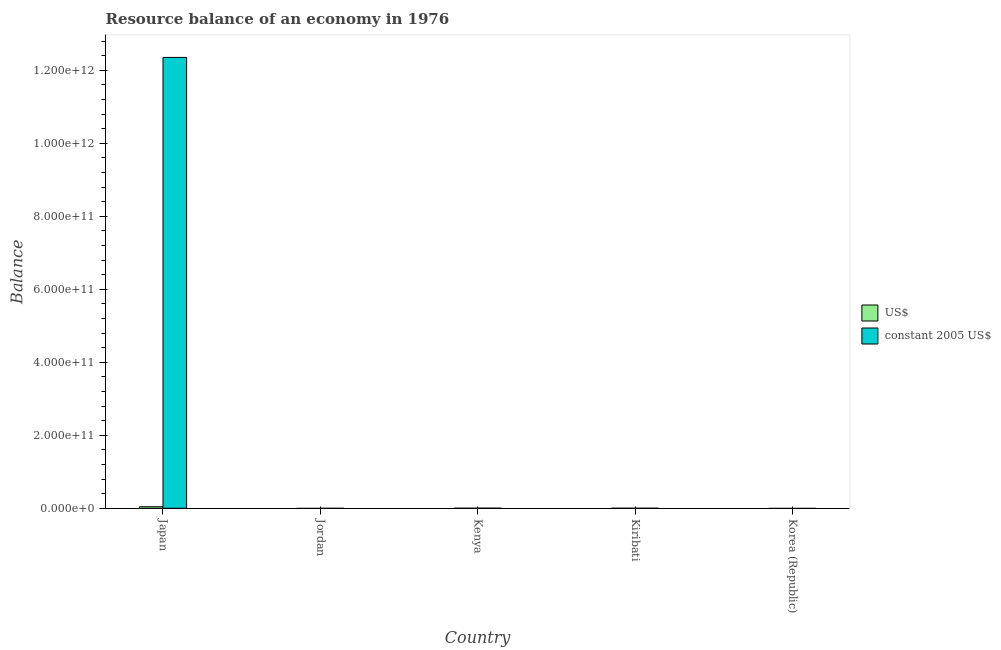How many different coloured bars are there?
Keep it short and to the point. 2. Are the number of bars per tick equal to the number of legend labels?
Provide a succinct answer. No. What is the label of the 2nd group of bars from the left?
Your response must be concise. Jordan. In how many cases, is the number of bars for a given country not equal to the number of legend labels?
Keep it short and to the point. 2. Across all countries, what is the maximum resource balance in us$?
Your answer should be compact. 4.17e+09. In which country was the resource balance in us$ maximum?
Provide a short and direct response. Japan. What is the total resource balance in us$ in the graph?
Offer a very short reply. 4.20e+09. What is the difference between the resource balance in constant us$ in Japan and that in Kiribati?
Your answer should be compact. 1.24e+12. What is the difference between the resource balance in constant us$ in Japan and the resource balance in us$ in Korea (Republic)?
Offer a terse response. 1.24e+12. What is the average resource balance in constant us$ per country?
Your response must be concise. 2.47e+11. What is the difference between the resource balance in constant us$ and resource balance in us$ in Kiribati?
Provide a short and direct response. -1.55e+06. What is the difference between the highest and the second highest resource balance in constant us$?
Ensure brevity in your answer.  1.24e+12. What is the difference between the highest and the lowest resource balance in us$?
Your answer should be compact. 4.17e+09. In how many countries, is the resource balance in us$ greater than the average resource balance in us$ taken over all countries?
Your response must be concise. 1. Is the sum of the resource balance in constant us$ in Kenya and Kiribati greater than the maximum resource balance in us$ across all countries?
Your response must be concise. No. How many bars are there?
Offer a terse response. 6. Are all the bars in the graph horizontal?
Give a very brief answer. No. How many countries are there in the graph?
Offer a very short reply. 5. What is the difference between two consecutive major ticks on the Y-axis?
Provide a short and direct response. 2.00e+11. Are the values on the major ticks of Y-axis written in scientific E-notation?
Your answer should be compact. Yes. Does the graph contain any zero values?
Provide a short and direct response. Yes. How many legend labels are there?
Make the answer very short. 2. How are the legend labels stacked?
Provide a short and direct response. Vertical. What is the title of the graph?
Provide a short and direct response. Resource balance of an economy in 1976. Does "From production" appear as one of the legend labels in the graph?
Offer a terse response. No. What is the label or title of the X-axis?
Provide a short and direct response. Country. What is the label or title of the Y-axis?
Ensure brevity in your answer.  Balance. What is the Balance in US$ in Japan?
Offer a terse response. 4.17e+09. What is the Balance in constant 2005 US$ in Japan?
Your response must be concise. 1.24e+12. What is the Balance of constant 2005 US$ in Jordan?
Make the answer very short. 0. What is the Balance of US$ in Kenya?
Provide a short and direct response. 2.41e+07. What is the Balance in constant 2005 US$ in Kenya?
Offer a terse response. 2.02e+08. What is the Balance of US$ in Kiribati?
Keep it short and to the point. 8.51e+06. What is the Balance in constant 2005 US$ in Kiribati?
Provide a succinct answer. 6.96e+06. What is the Balance in US$ in Korea (Republic)?
Your answer should be compact. 0. What is the Balance in constant 2005 US$ in Korea (Republic)?
Provide a short and direct response. 0. Across all countries, what is the maximum Balance in US$?
Keep it short and to the point. 4.17e+09. Across all countries, what is the maximum Balance of constant 2005 US$?
Ensure brevity in your answer.  1.24e+12. Across all countries, what is the minimum Balance of US$?
Give a very brief answer. 0. What is the total Balance in US$ in the graph?
Your answer should be compact. 4.20e+09. What is the total Balance of constant 2005 US$ in the graph?
Your answer should be compact. 1.24e+12. What is the difference between the Balance in US$ in Japan and that in Kenya?
Your answer should be compact. 4.14e+09. What is the difference between the Balance in constant 2005 US$ in Japan and that in Kenya?
Offer a very short reply. 1.24e+12. What is the difference between the Balance in US$ in Japan and that in Kiribati?
Offer a terse response. 4.16e+09. What is the difference between the Balance of constant 2005 US$ in Japan and that in Kiribati?
Ensure brevity in your answer.  1.24e+12. What is the difference between the Balance of US$ in Kenya and that in Kiribati?
Provide a succinct answer. 1.56e+07. What is the difference between the Balance in constant 2005 US$ in Kenya and that in Kiribati?
Your answer should be compact. 1.95e+08. What is the difference between the Balance in US$ in Japan and the Balance in constant 2005 US$ in Kenya?
Offer a very short reply. 3.96e+09. What is the difference between the Balance in US$ in Japan and the Balance in constant 2005 US$ in Kiribati?
Your response must be concise. 4.16e+09. What is the difference between the Balance in US$ in Kenya and the Balance in constant 2005 US$ in Kiribati?
Provide a short and direct response. 1.72e+07. What is the average Balance in US$ per country?
Provide a short and direct response. 8.40e+08. What is the average Balance in constant 2005 US$ per country?
Offer a very short reply. 2.47e+11. What is the difference between the Balance of US$ and Balance of constant 2005 US$ in Japan?
Offer a terse response. -1.23e+12. What is the difference between the Balance in US$ and Balance in constant 2005 US$ in Kenya?
Offer a very short reply. -1.78e+08. What is the difference between the Balance in US$ and Balance in constant 2005 US$ in Kiribati?
Make the answer very short. 1.55e+06. What is the ratio of the Balance of US$ in Japan to that in Kenya?
Provide a succinct answer. 172.54. What is the ratio of the Balance of constant 2005 US$ in Japan to that in Kenya?
Offer a terse response. 6115.22. What is the ratio of the Balance in US$ in Japan to that in Kiribati?
Offer a terse response. 489.53. What is the ratio of the Balance of constant 2005 US$ in Japan to that in Kiribati?
Offer a terse response. 1.77e+05. What is the ratio of the Balance in US$ in Kenya to that in Kiribati?
Make the answer very short. 2.84. What is the ratio of the Balance of constant 2005 US$ in Kenya to that in Kiribati?
Keep it short and to the point. 29.01. What is the difference between the highest and the second highest Balance in US$?
Provide a succinct answer. 4.14e+09. What is the difference between the highest and the second highest Balance of constant 2005 US$?
Keep it short and to the point. 1.24e+12. What is the difference between the highest and the lowest Balance in US$?
Offer a terse response. 4.17e+09. What is the difference between the highest and the lowest Balance of constant 2005 US$?
Offer a terse response. 1.24e+12. 